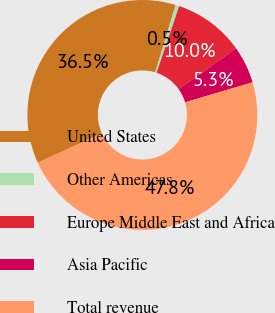Convert chart to OTSL. <chart><loc_0><loc_0><loc_500><loc_500><pie_chart><fcel>United States<fcel>Other Americas<fcel>Europe Middle East and Africa<fcel>Asia Pacific<fcel>Total revenue<nl><fcel>36.48%<fcel>0.52%<fcel>9.97%<fcel>5.25%<fcel>47.77%<nl></chart> 